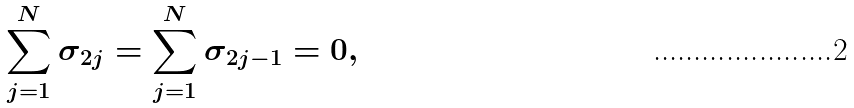<formula> <loc_0><loc_0><loc_500><loc_500>\sum _ { j = 1 } ^ { N } \sigma _ { 2 j } = \sum _ { j = 1 } ^ { N } \sigma _ { 2 j - 1 } = 0 ,</formula> 